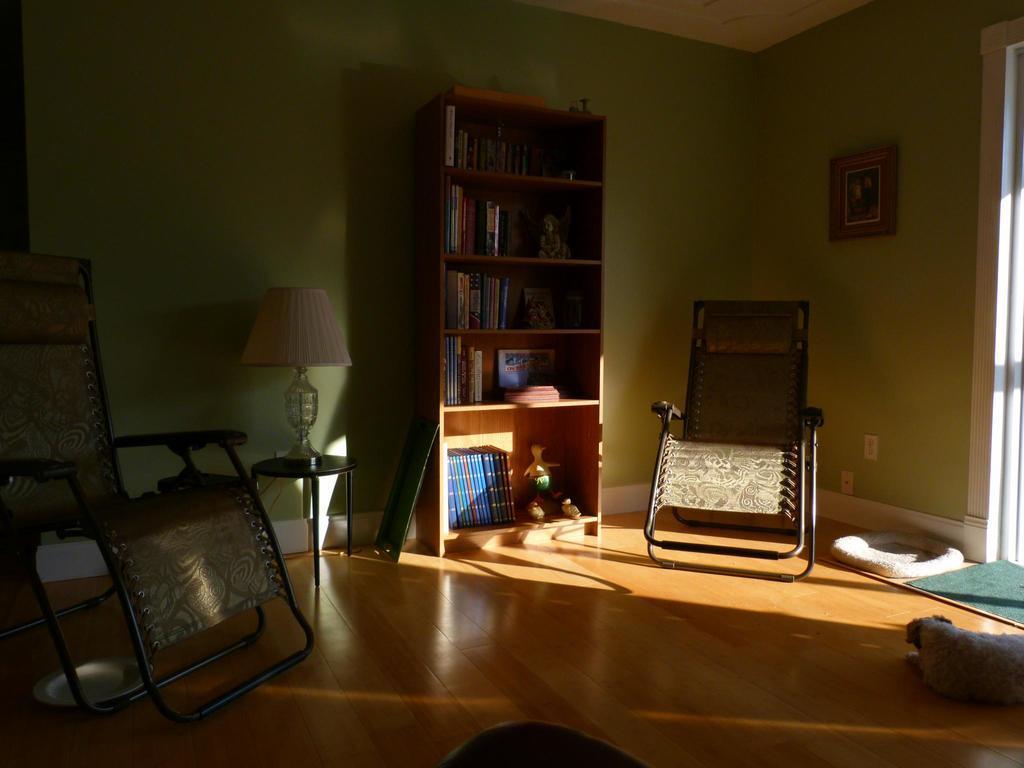In one or two sentences, can you explain what this image depicts? In this image I can see the brown colored floor, two chairs, an animal lying on the floor, a table with a lamp on it, a bookshelf with number of books and few other objects in it. In the background I can see the green colored wall, the ceiling and a photo frame attached to the wall. 